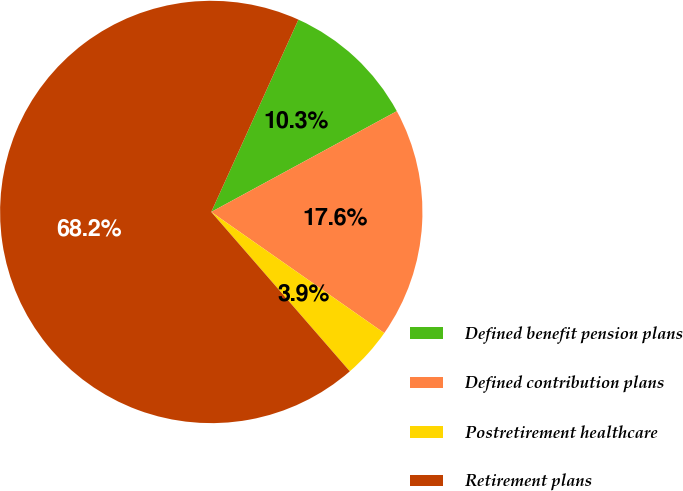Convert chart. <chart><loc_0><loc_0><loc_500><loc_500><pie_chart><fcel>Defined benefit pension plans<fcel>Defined contribution plans<fcel>Postretirement healthcare<fcel>Retirement plans<nl><fcel>10.31%<fcel>17.64%<fcel>3.89%<fcel>68.16%<nl></chart> 